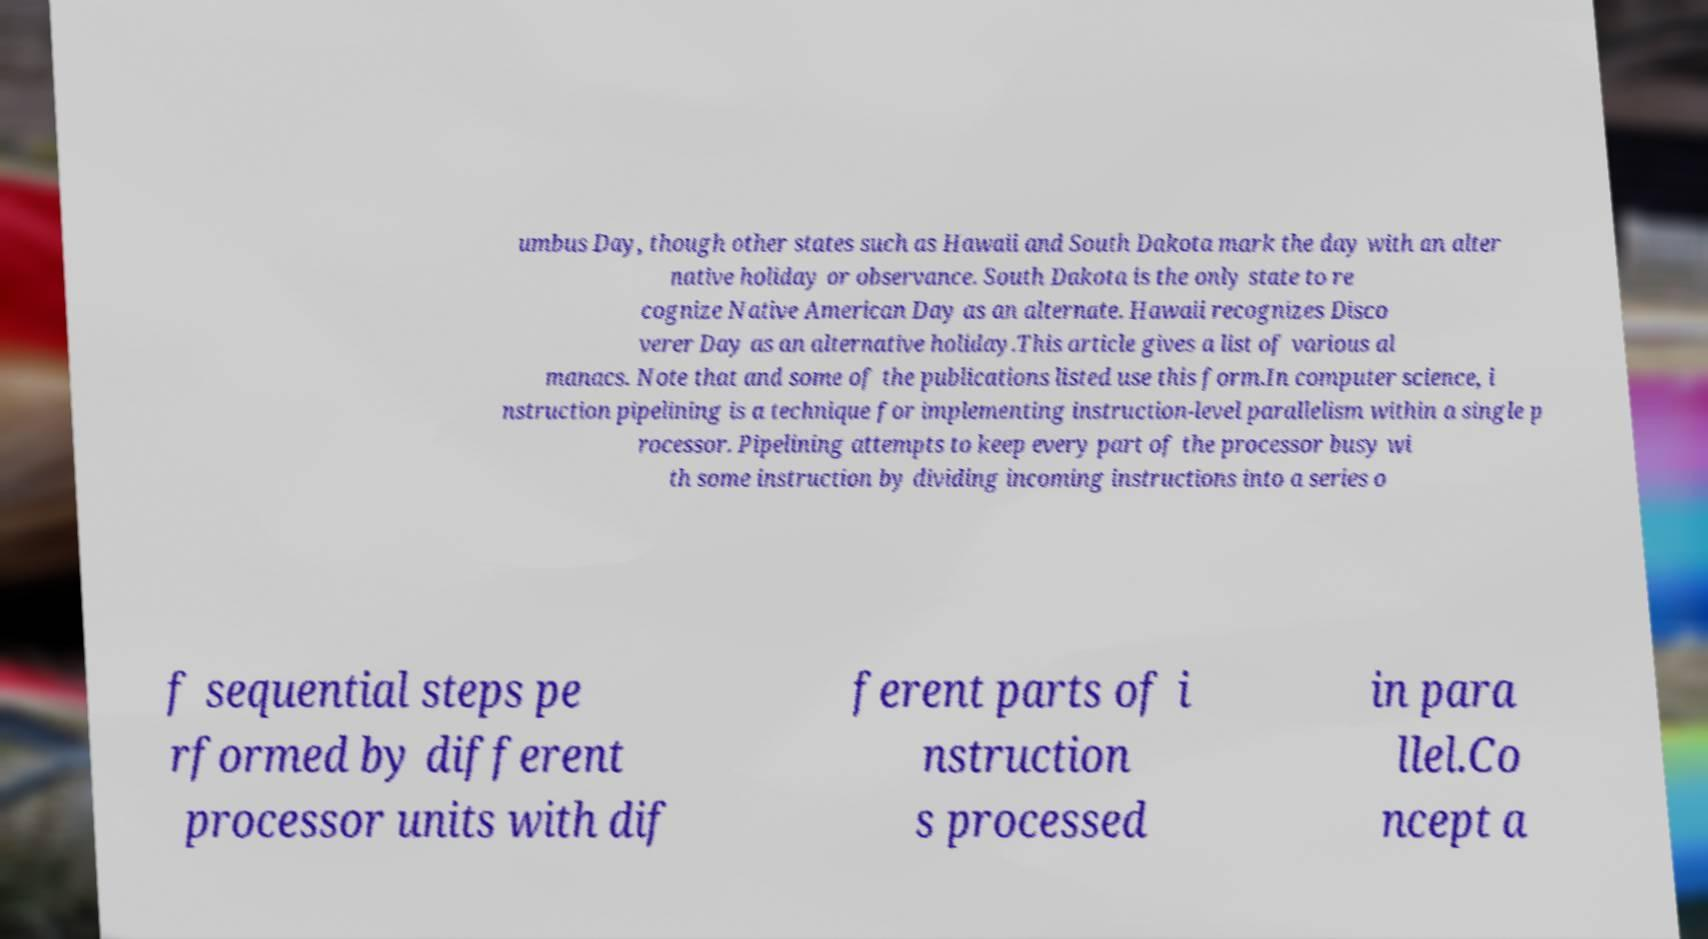Please identify and transcribe the text found in this image. umbus Day, though other states such as Hawaii and South Dakota mark the day with an alter native holiday or observance. South Dakota is the only state to re cognize Native American Day as an alternate. Hawaii recognizes Disco verer Day as an alternative holiday.This article gives a list of various al manacs. Note that and some of the publications listed use this form.In computer science, i nstruction pipelining is a technique for implementing instruction-level parallelism within a single p rocessor. Pipelining attempts to keep every part of the processor busy wi th some instruction by dividing incoming instructions into a series o f sequential steps pe rformed by different processor units with dif ferent parts of i nstruction s processed in para llel.Co ncept a 